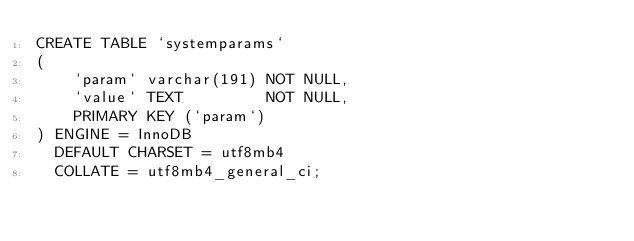Convert code to text. <code><loc_0><loc_0><loc_500><loc_500><_SQL_>CREATE TABLE `systemparams`
(
    `param` varchar(191) NOT NULL,
    `value` TEXT         NOT NULL,
    PRIMARY KEY (`param`)
) ENGINE = InnoDB
  DEFAULT CHARSET = utf8mb4
  COLLATE = utf8mb4_general_ci;
</code> 